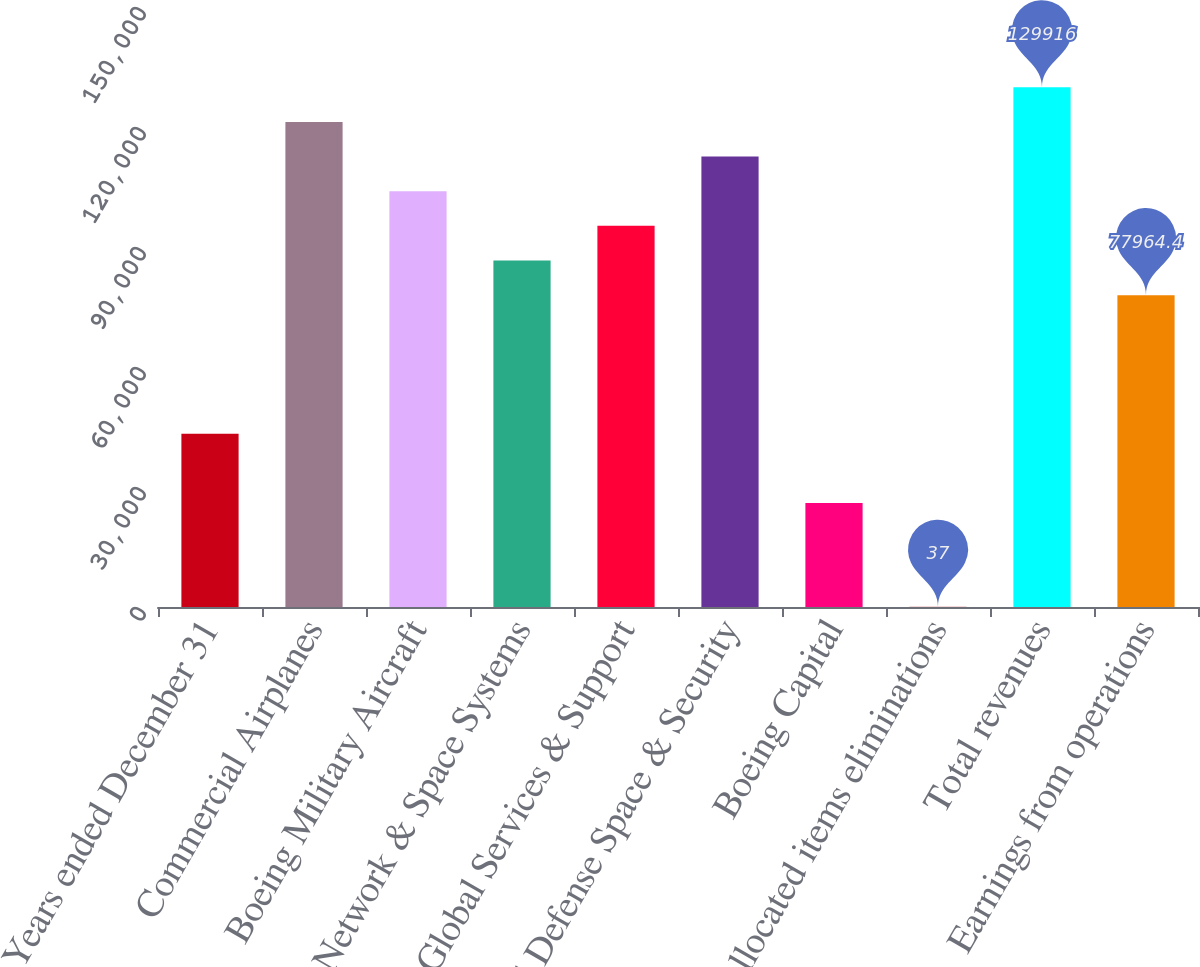Convert chart. <chart><loc_0><loc_0><loc_500><loc_500><bar_chart><fcel>Years ended December 31<fcel>Commercial Airplanes<fcel>Boeing Military Aircraft<fcel>Network & Space Systems<fcel>Global Services & Support<fcel>Total Defense Space & Security<fcel>Boeing Capital<fcel>Unallocated items eliminations<fcel>Total revenues<fcel>Earnings from operations<nl><fcel>43330<fcel>121257<fcel>103940<fcel>86623<fcel>95281.6<fcel>112599<fcel>26012.8<fcel>37<fcel>129916<fcel>77964.4<nl></chart> 